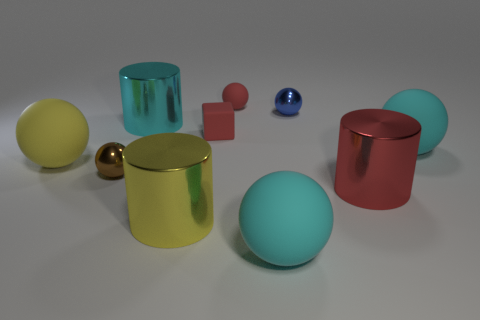Subtract all cyan cylinders. How many cylinders are left? 2 Subtract all red spheres. How many spheres are left? 5 Subtract 3 spheres. How many spheres are left? 3 Add 7 red metal cylinders. How many red metal cylinders exist? 8 Subtract 0 yellow cubes. How many objects are left? 10 Subtract all blocks. How many objects are left? 9 Subtract all purple cylinders. Subtract all blue cubes. How many cylinders are left? 3 Subtract all brown cubes. How many purple spheres are left? 0 Subtract all blocks. Subtract all big rubber balls. How many objects are left? 6 Add 2 cyan rubber things. How many cyan rubber things are left? 4 